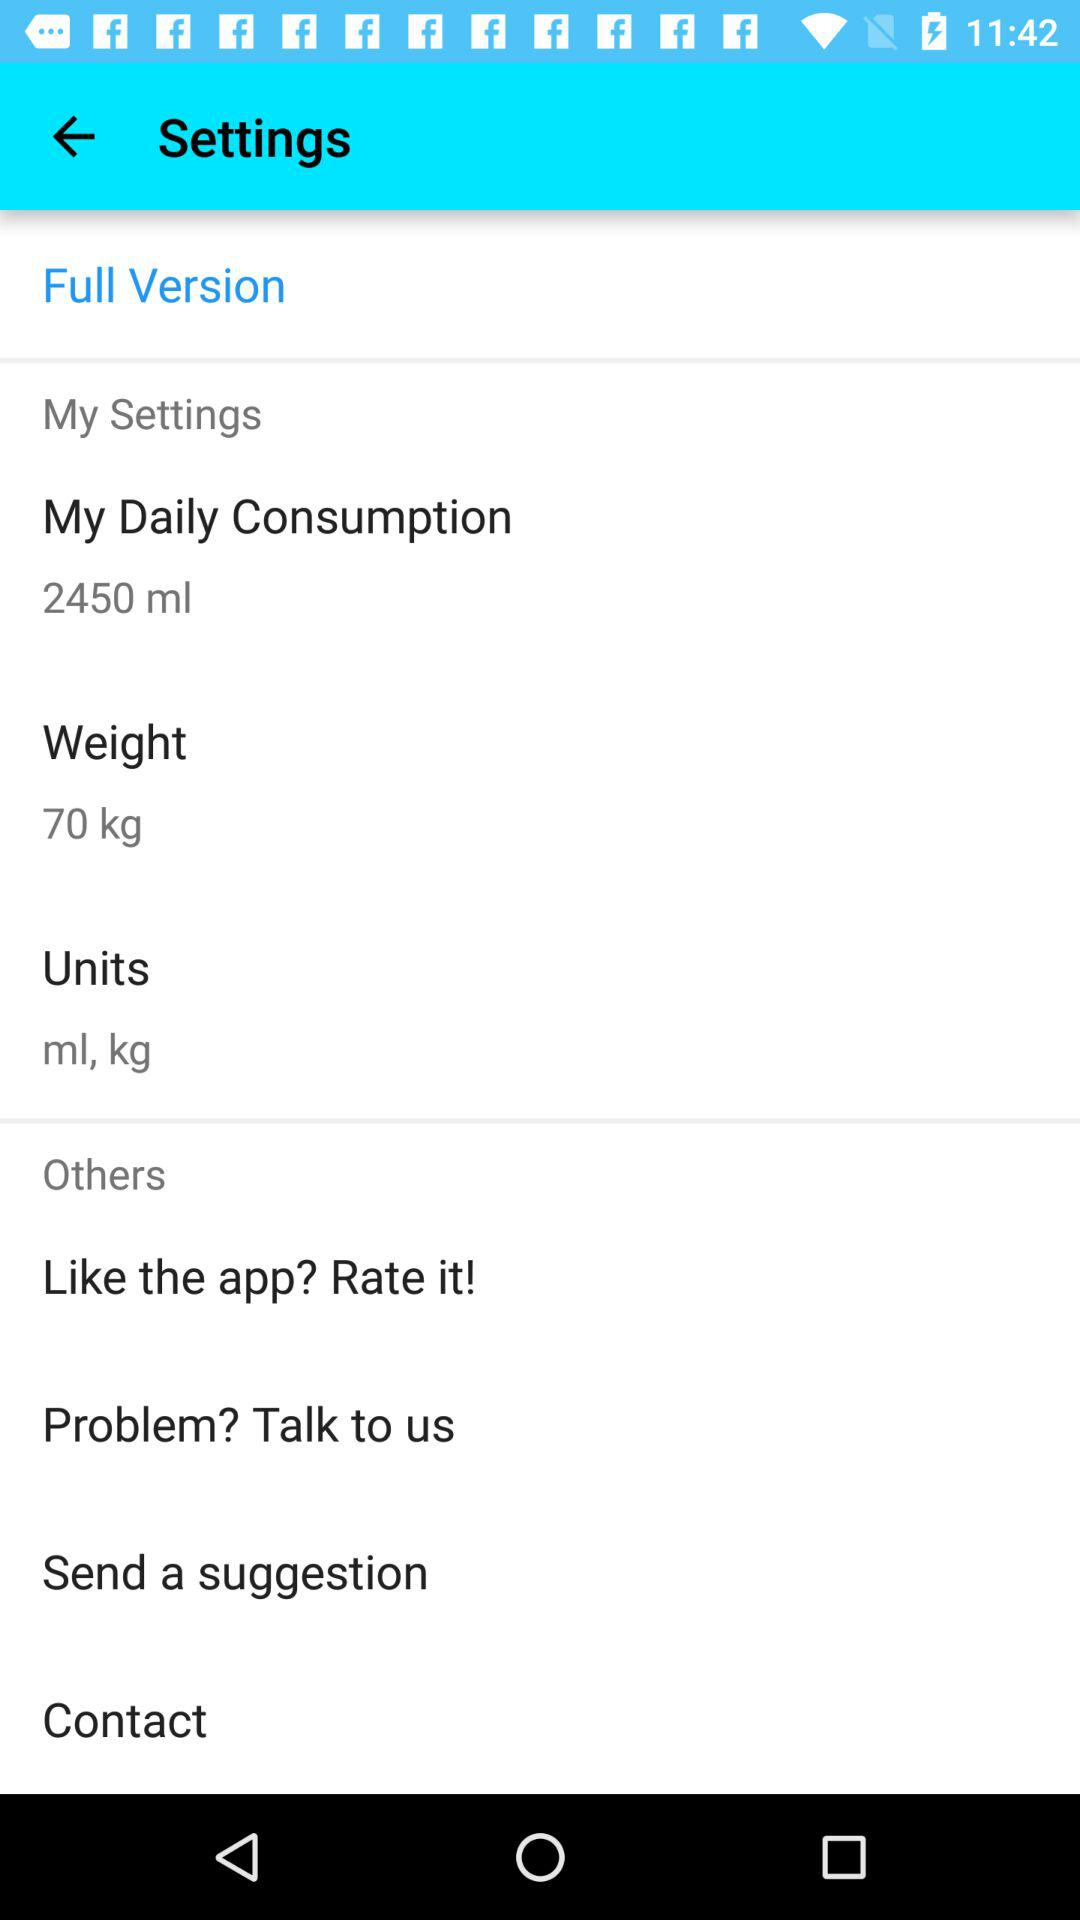What is my daily consumption? Your daily consumption is 2450 ml. 